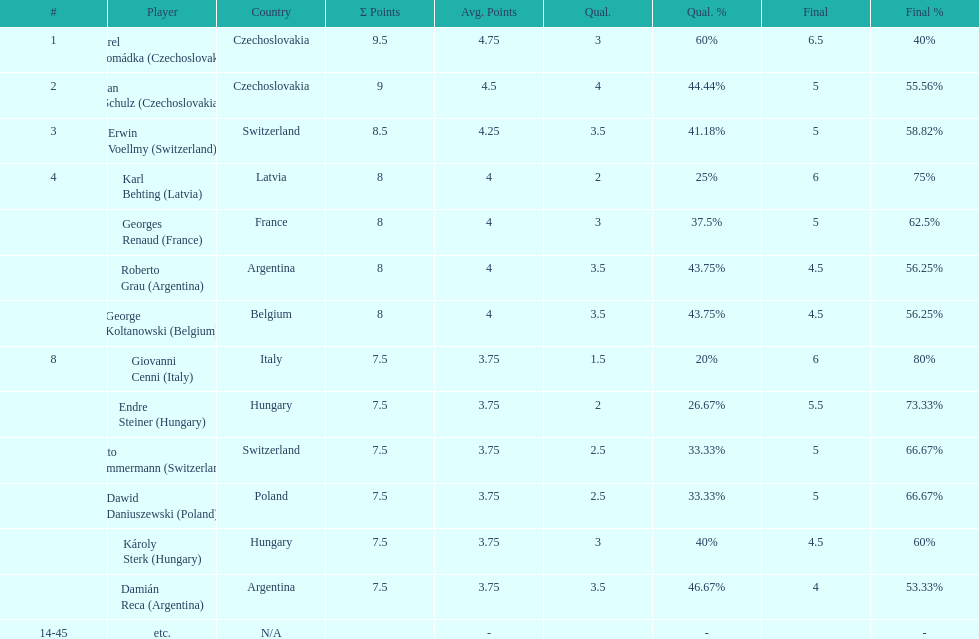Which player had the largest number of &#931; points? Karel Hromádka. 